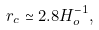Convert formula to latex. <formula><loc_0><loc_0><loc_500><loc_500>r _ { c } \simeq 2 . 8 H _ { o } ^ { - 1 } ,</formula> 